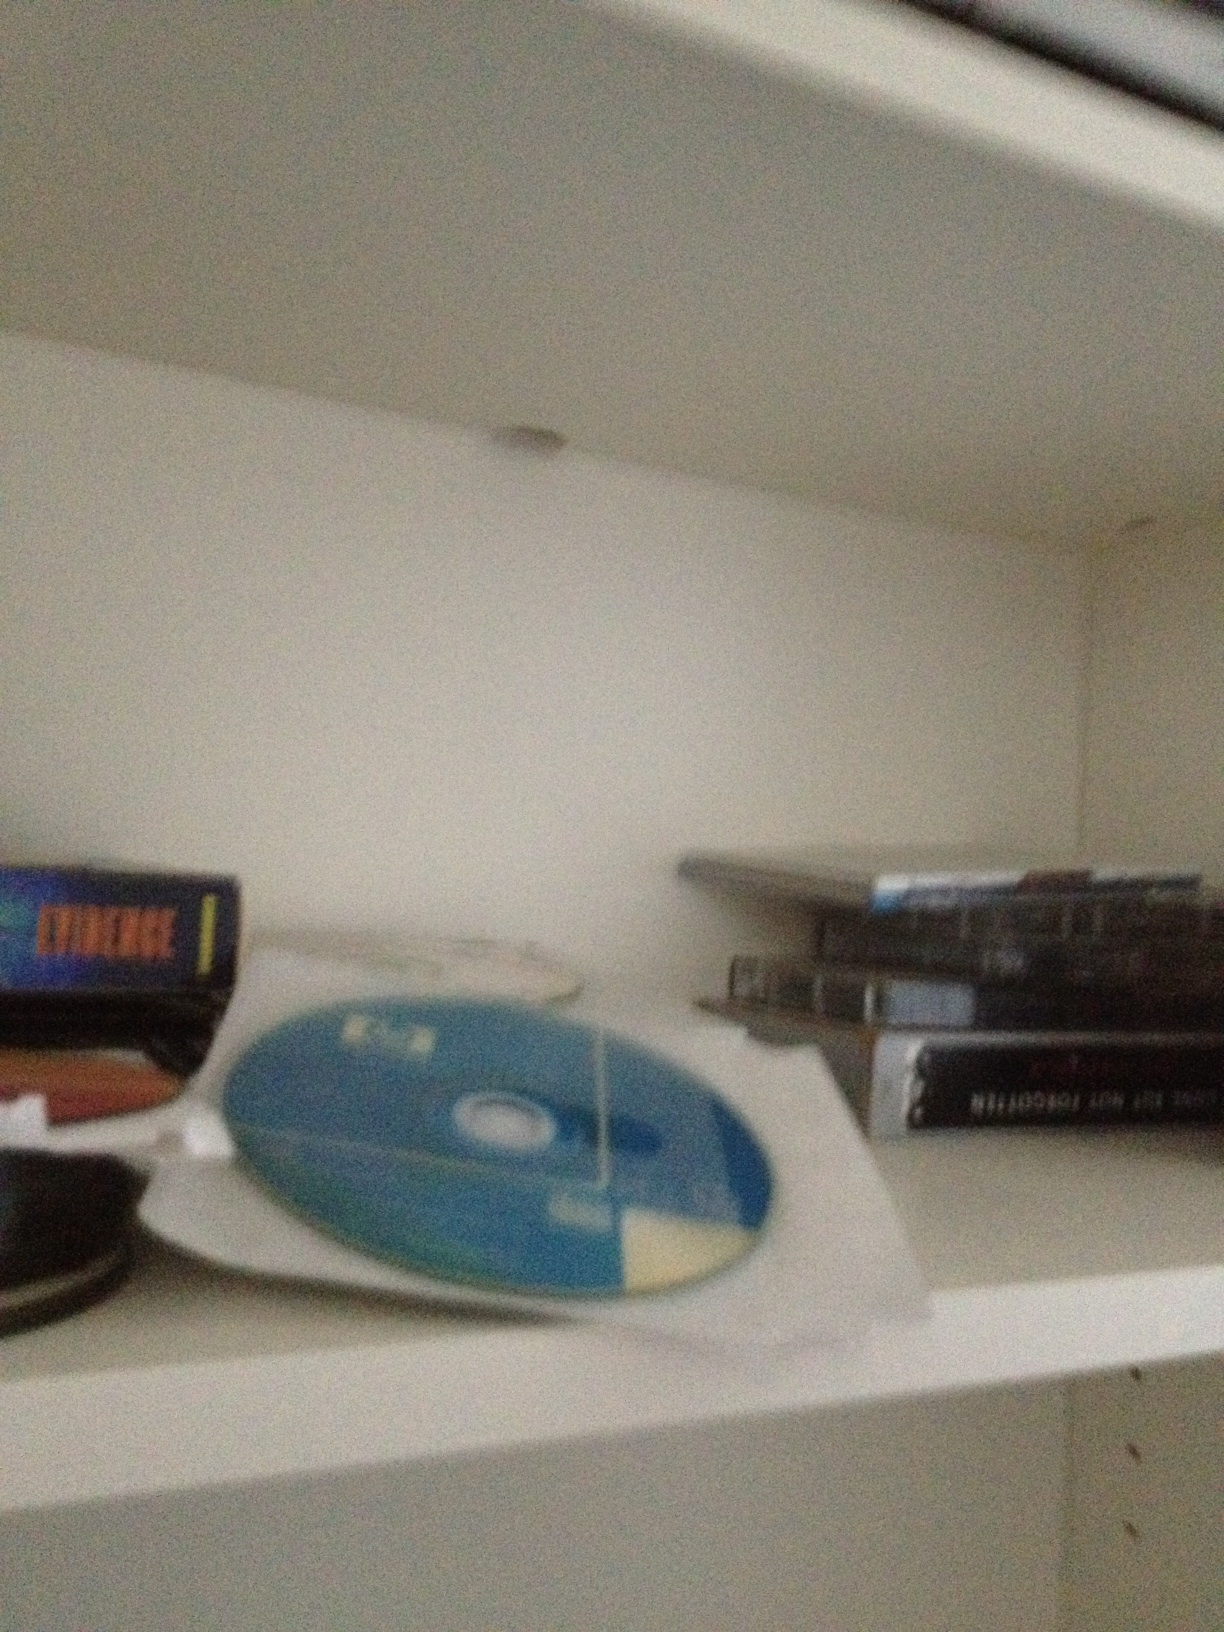What's in the photo? The photo shows a shelf with several CDs and DVDs, some in cases and others loose. There are also some other small items that appear to be stacked near the CDs, such as perhaps some video game or software boxes. 